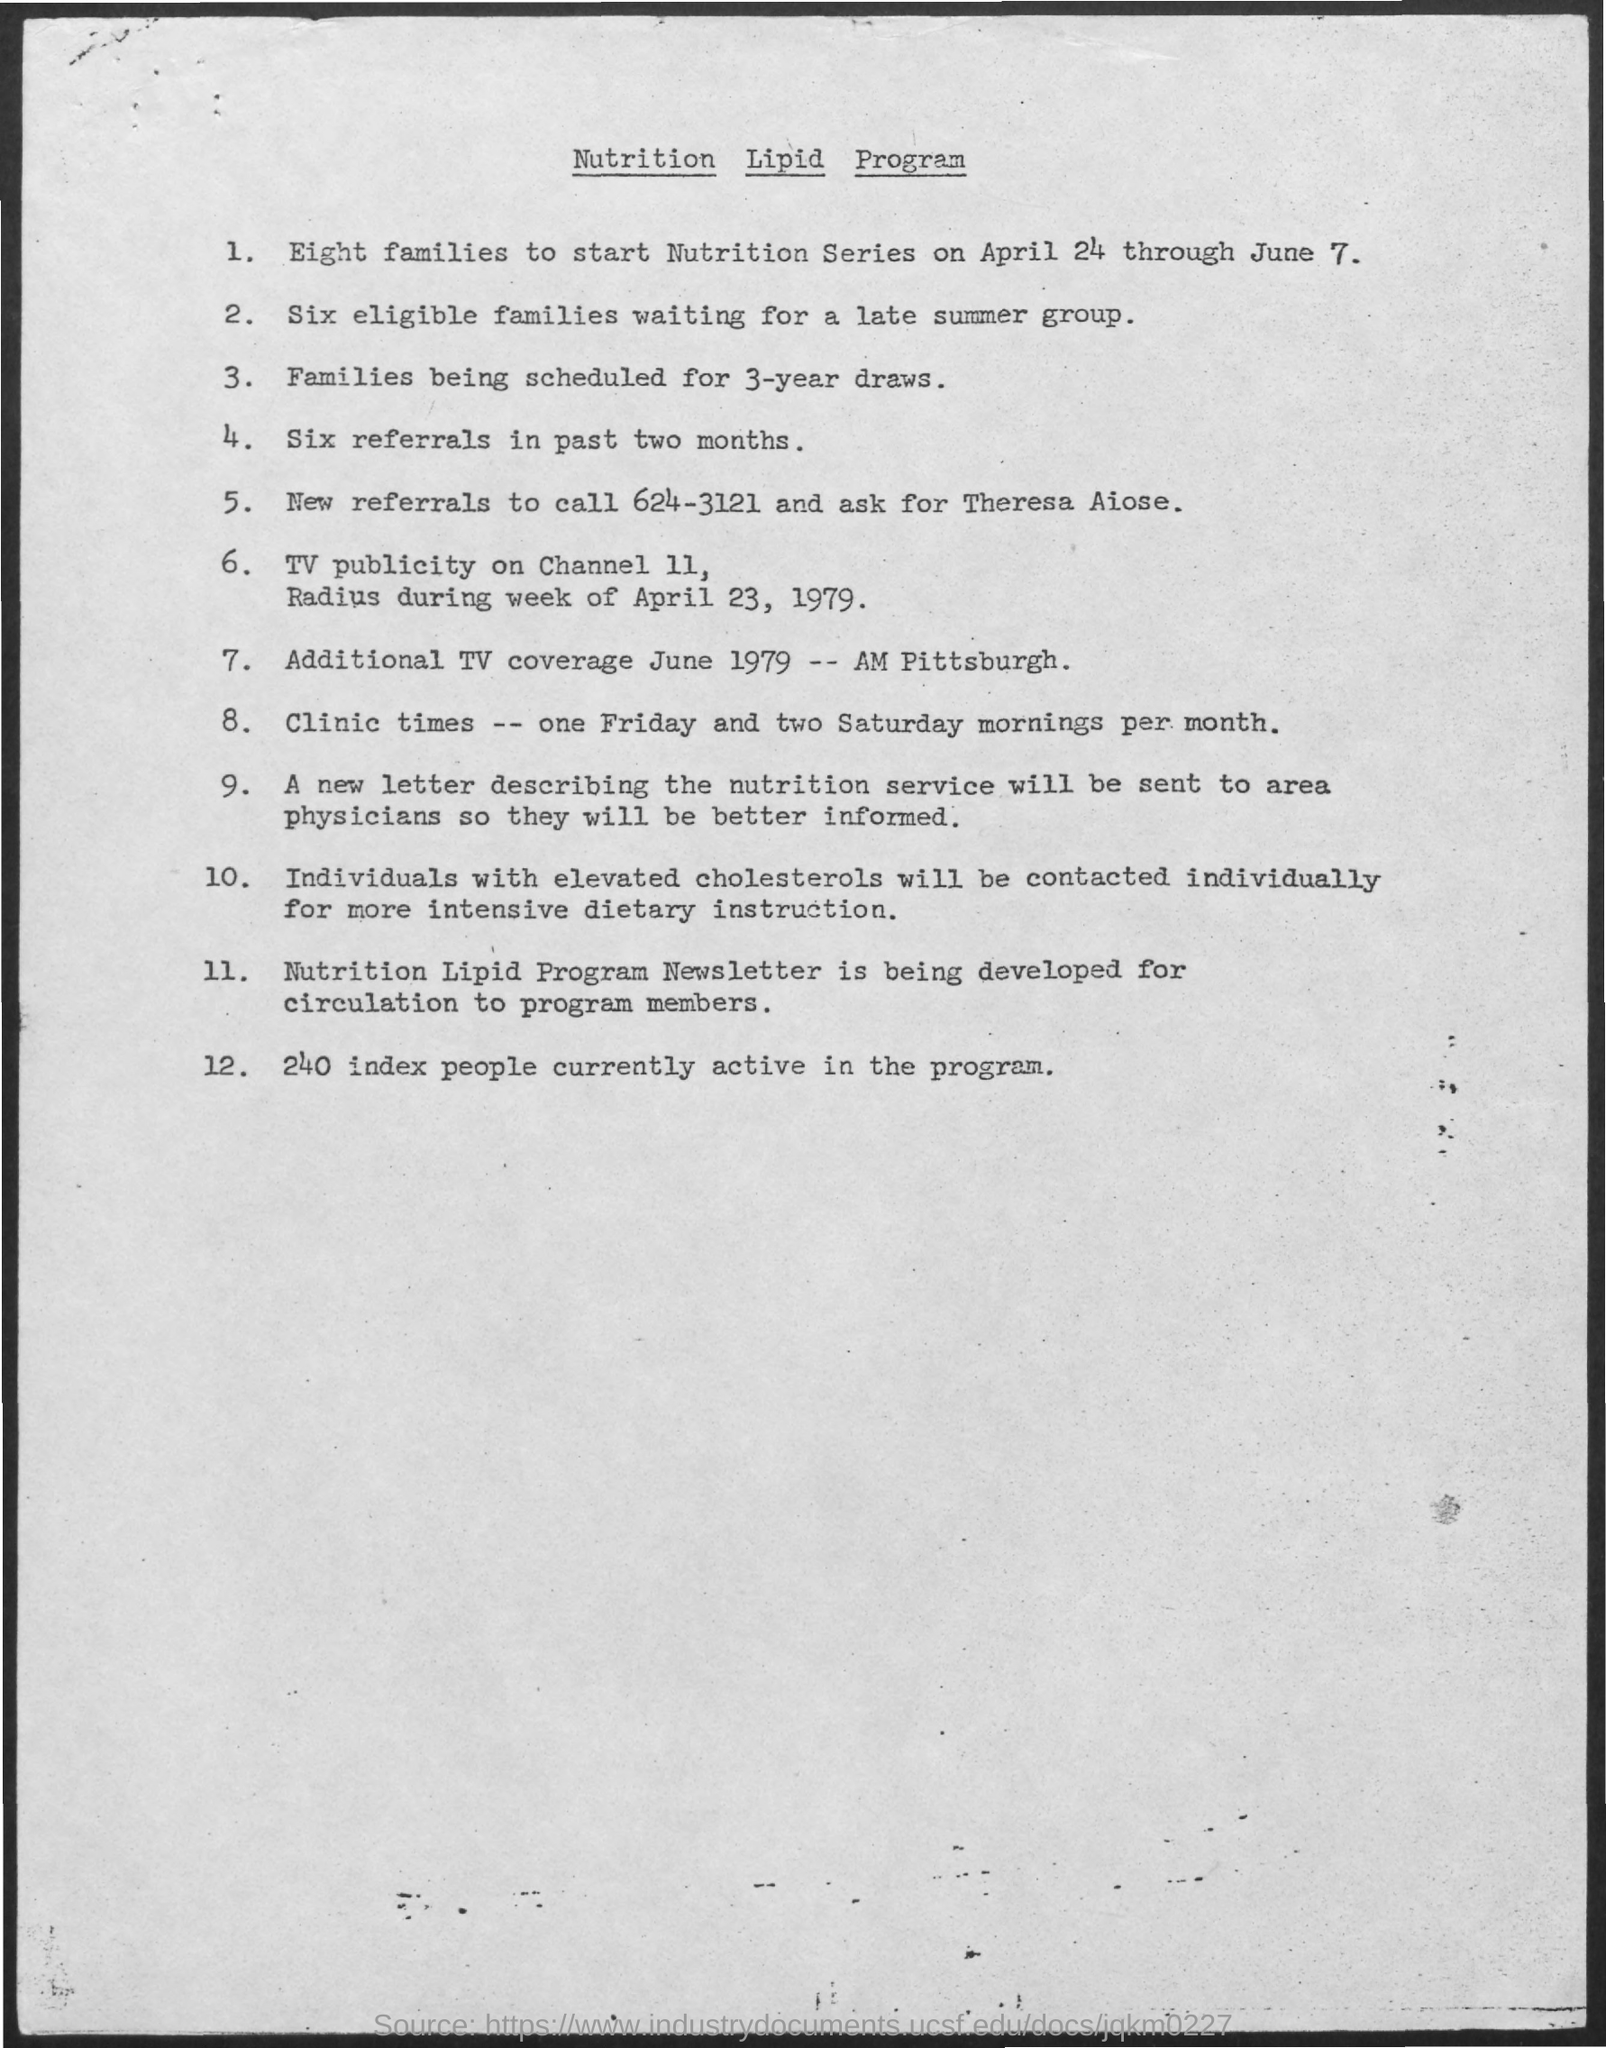List a handful of essential elements in this visual. The TV advertisement will air on Channel 11. The name of the nutrition lipid program is... As of now, there are approximately 240 active individuals participating in the program. The number for new referrals to call is 624-3121. 